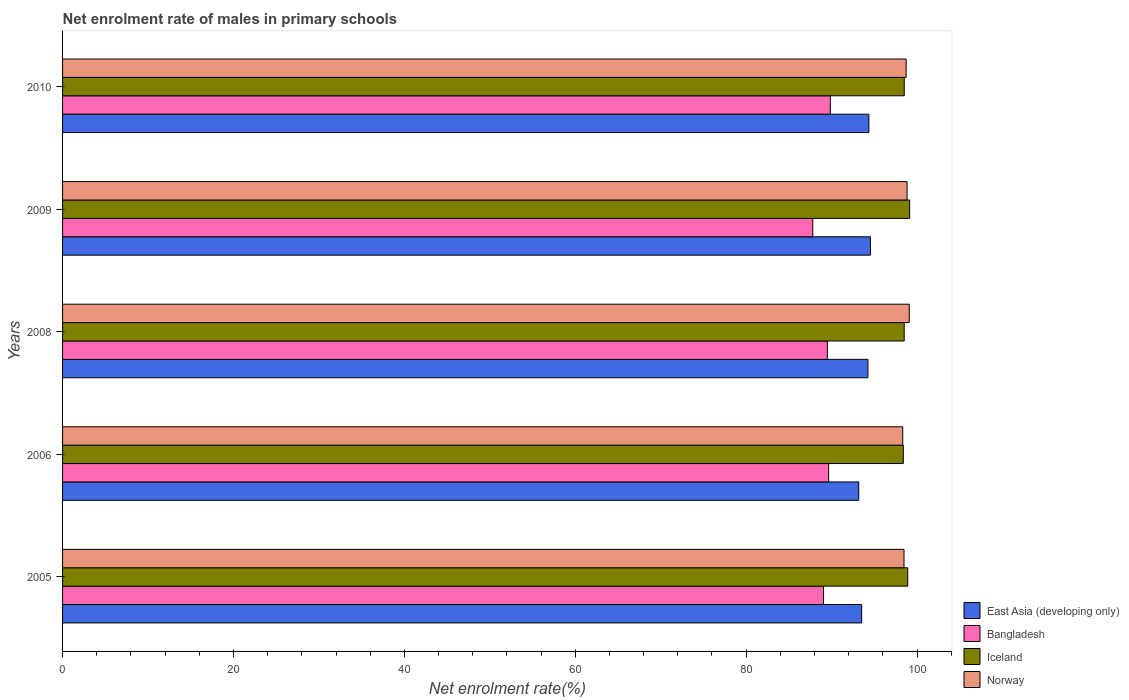How many groups of bars are there?
Ensure brevity in your answer.  5. Are the number of bars per tick equal to the number of legend labels?
Your answer should be very brief. Yes. Are the number of bars on each tick of the Y-axis equal?
Keep it short and to the point. Yes. How many bars are there on the 2nd tick from the top?
Offer a terse response. 4. How many bars are there on the 3rd tick from the bottom?
Provide a short and direct response. 4. What is the label of the 1st group of bars from the top?
Your answer should be compact. 2010. In how many cases, is the number of bars for a given year not equal to the number of legend labels?
Make the answer very short. 0. What is the net enrolment rate of males in primary schools in Norway in 2010?
Offer a very short reply. 98.72. Across all years, what is the maximum net enrolment rate of males in primary schools in Bangladesh?
Ensure brevity in your answer.  89.85. Across all years, what is the minimum net enrolment rate of males in primary schools in Iceland?
Offer a very short reply. 98.39. In which year was the net enrolment rate of males in primary schools in East Asia (developing only) maximum?
Give a very brief answer. 2009. In which year was the net enrolment rate of males in primary schools in Iceland minimum?
Your answer should be compact. 2006. What is the total net enrolment rate of males in primary schools in Iceland in the graph?
Provide a succinct answer. 493.43. What is the difference between the net enrolment rate of males in primary schools in East Asia (developing only) in 2005 and that in 2006?
Make the answer very short. 0.34. What is the difference between the net enrolment rate of males in primary schools in Norway in 2010 and the net enrolment rate of males in primary schools in East Asia (developing only) in 2008?
Offer a very short reply. 4.47. What is the average net enrolment rate of males in primary schools in Iceland per year?
Your answer should be compact. 98.69. In the year 2010, what is the difference between the net enrolment rate of males in primary schools in Iceland and net enrolment rate of males in primary schools in Bangladesh?
Your answer should be compact. 8.66. In how many years, is the net enrolment rate of males in primary schools in Bangladesh greater than 24 %?
Your answer should be very brief. 5. What is the ratio of the net enrolment rate of males in primary schools in Iceland in 2006 to that in 2009?
Keep it short and to the point. 0.99. Is the net enrolment rate of males in primary schools in Bangladesh in 2005 less than that in 2010?
Give a very brief answer. Yes. What is the difference between the highest and the second highest net enrolment rate of males in primary schools in Iceland?
Ensure brevity in your answer.  0.22. What is the difference between the highest and the lowest net enrolment rate of males in primary schools in Iceland?
Keep it short and to the point. 0.74. Is it the case that in every year, the sum of the net enrolment rate of males in primary schools in East Asia (developing only) and net enrolment rate of males in primary schools in Bangladesh is greater than the sum of net enrolment rate of males in primary schools in Iceland and net enrolment rate of males in primary schools in Norway?
Provide a short and direct response. Yes. What does the 4th bar from the top in 2010 represents?
Make the answer very short. East Asia (developing only). Are all the bars in the graph horizontal?
Give a very brief answer. Yes. How many years are there in the graph?
Offer a very short reply. 5. What is the difference between two consecutive major ticks on the X-axis?
Ensure brevity in your answer.  20. Does the graph contain grids?
Give a very brief answer. No. What is the title of the graph?
Ensure brevity in your answer.  Net enrolment rate of males in primary schools. Does "Nigeria" appear as one of the legend labels in the graph?
Your answer should be very brief. No. What is the label or title of the X-axis?
Ensure brevity in your answer.  Net enrolment rate(%). What is the label or title of the Y-axis?
Make the answer very short. Years. What is the Net enrolment rate(%) of East Asia (developing only) in 2005?
Your answer should be compact. 93.52. What is the Net enrolment rate(%) in Bangladesh in 2005?
Provide a short and direct response. 89.05. What is the Net enrolment rate(%) of Iceland in 2005?
Provide a short and direct response. 98.91. What is the Net enrolment rate(%) of Norway in 2005?
Make the answer very short. 98.47. What is the Net enrolment rate(%) in East Asia (developing only) in 2006?
Offer a terse response. 93.17. What is the Net enrolment rate(%) in Bangladesh in 2006?
Your answer should be very brief. 89.65. What is the Net enrolment rate(%) of Iceland in 2006?
Give a very brief answer. 98.39. What is the Net enrolment rate(%) of Norway in 2006?
Give a very brief answer. 98.32. What is the Net enrolment rate(%) of East Asia (developing only) in 2008?
Provide a succinct answer. 94.25. What is the Net enrolment rate(%) of Bangladesh in 2008?
Provide a short and direct response. 89.5. What is the Net enrolment rate(%) in Iceland in 2008?
Provide a short and direct response. 98.49. What is the Net enrolment rate(%) of Norway in 2008?
Make the answer very short. 99.09. What is the Net enrolment rate(%) in East Asia (developing only) in 2009?
Your answer should be very brief. 94.54. What is the Net enrolment rate(%) of Bangladesh in 2009?
Keep it short and to the point. 87.79. What is the Net enrolment rate(%) in Iceland in 2009?
Your answer should be very brief. 99.13. What is the Net enrolment rate(%) of Norway in 2009?
Offer a terse response. 98.83. What is the Net enrolment rate(%) of East Asia (developing only) in 2010?
Give a very brief answer. 94.37. What is the Net enrolment rate(%) in Bangladesh in 2010?
Your answer should be compact. 89.85. What is the Net enrolment rate(%) of Iceland in 2010?
Give a very brief answer. 98.5. What is the Net enrolment rate(%) of Norway in 2010?
Your answer should be compact. 98.72. Across all years, what is the maximum Net enrolment rate(%) of East Asia (developing only)?
Offer a terse response. 94.54. Across all years, what is the maximum Net enrolment rate(%) of Bangladesh?
Ensure brevity in your answer.  89.85. Across all years, what is the maximum Net enrolment rate(%) in Iceland?
Offer a terse response. 99.13. Across all years, what is the maximum Net enrolment rate(%) of Norway?
Make the answer very short. 99.09. Across all years, what is the minimum Net enrolment rate(%) in East Asia (developing only)?
Offer a terse response. 93.17. Across all years, what is the minimum Net enrolment rate(%) of Bangladesh?
Keep it short and to the point. 87.79. Across all years, what is the minimum Net enrolment rate(%) of Iceland?
Offer a very short reply. 98.39. Across all years, what is the minimum Net enrolment rate(%) of Norway?
Your answer should be compact. 98.32. What is the total Net enrolment rate(%) in East Asia (developing only) in the graph?
Your answer should be very brief. 469.85. What is the total Net enrolment rate(%) of Bangladesh in the graph?
Give a very brief answer. 445.85. What is the total Net enrolment rate(%) in Iceland in the graph?
Your answer should be compact. 493.43. What is the total Net enrolment rate(%) of Norway in the graph?
Offer a terse response. 493.43. What is the difference between the Net enrolment rate(%) in East Asia (developing only) in 2005 and that in 2006?
Ensure brevity in your answer.  0.34. What is the difference between the Net enrolment rate(%) of Bangladesh in 2005 and that in 2006?
Offer a very short reply. -0.6. What is the difference between the Net enrolment rate(%) of Iceland in 2005 and that in 2006?
Your answer should be compact. 0.52. What is the difference between the Net enrolment rate(%) in Norway in 2005 and that in 2006?
Your answer should be compact. 0.15. What is the difference between the Net enrolment rate(%) of East Asia (developing only) in 2005 and that in 2008?
Provide a short and direct response. -0.73. What is the difference between the Net enrolment rate(%) in Bangladesh in 2005 and that in 2008?
Keep it short and to the point. -0.45. What is the difference between the Net enrolment rate(%) of Iceland in 2005 and that in 2008?
Offer a terse response. 0.42. What is the difference between the Net enrolment rate(%) in Norway in 2005 and that in 2008?
Make the answer very short. -0.61. What is the difference between the Net enrolment rate(%) in East Asia (developing only) in 2005 and that in 2009?
Give a very brief answer. -1.02. What is the difference between the Net enrolment rate(%) in Bangladesh in 2005 and that in 2009?
Give a very brief answer. 1.26. What is the difference between the Net enrolment rate(%) of Iceland in 2005 and that in 2009?
Give a very brief answer. -0.22. What is the difference between the Net enrolment rate(%) of Norway in 2005 and that in 2009?
Make the answer very short. -0.36. What is the difference between the Net enrolment rate(%) in East Asia (developing only) in 2005 and that in 2010?
Make the answer very short. -0.85. What is the difference between the Net enrolment rate(%) in Bangladesh in 2005 and that in 2010?
Keep it short and to the point. -0.79. What is the difference between the Net enrolment rate(%) of Iceland in 2005 and that in 2010?
Your answer should be very brief. 0.41. What is the difference between the Net enrolment rate(%) in Norway in 2005 and that in 2010?
Provide a succinct answer. -0.25. What is the difference between the Net enrolment rate(%) in East Asia (developing only) in 2006 and that in 2008?
Offer a terse response. -1.08. What is the difference between the Net enrolment rate(%) in Bangladesh in 2006 and that in 2008?
Give a very brief answer. 0.15. What is the difference between the Net enrolment rate(%) of Iceland in 2006 and that in 2008?
Offer a very short reply. -0.1. What is the difference between the Net enrolment rate(%) in Norway in 2006 and that in 2008?
Offer a terse response. -0.76. What is the difference between the Net enrolment rate(%) in East Asia (developing only) in 2006 and that in 2009?
Make the answer very short. -1.37. What is the difference between the Net enrolment rate(%) of Bangladesh in 2006 and that in 2009?
Make the answer very short. 1.86. What is the difference between the Net enrolment rate(%) of Iceland in 2006 and that in 2009?
Provide a succinct answer. -0.74. What is the difference between the Net enrolment rate(%) of Norway in 2006 and that in 2009?
Your answer should be very brief. -0.51. What is the difference between the Net enrolment rate(%) in East Asia (developing only) in 2006 and that in 2010?
Provide a succinct answer. -1.19. What is the difference between the Net enrolment rate(%) of Bangladesh in 2006 and that in 2010?
Make the answer very short. -0.19. What is the difference between the Net enrolment rate(%) of Iceland in 2006 and that in 2010?
Your answer should be compact. -0.11. What is the difference between the Net enrolment rate(%) in Norway in 2006 and that in 2010?
Make the answer very short. -0.4. What is the difference between the Net enrolment rate(%) of East Asia (developing only) in 2008 and that in 2009?
Provide a short and direct response. -0.29. What is the difference between the Net enrolment rate(%) in Bangladesh in 2008 and that in 2009?
Your answer should be compact. 1.71. What is the difference between the Net enrolment rate(%) in Iceland in 2008 and that in 2009?
Offer a very short reply. -0.64. What is the difference between the Net enrolment rate(%) of Norway in 2008 and that in 2009?
Provide a short and direct response. 0.26. What is the difference between the Net enrolment rate(%) of East Asia (developing only) in 2008 and that in 2010?
Make the answer very short. -0.11. What is the difference between the Net enrolment rate(%) of Bangladesh in 2008 and that in 2010?
Your answer should be very brief. -0.34. What is the difference between the Net enrolment rate(%) of Iceland in 2008 and that in 2010?
Offer a terse response. -0.01. What is the difference between the Net enrolment rate(%) in Norway in 2008 and that in 2010?
Your answer should be very brief. 0.36. What is the difference between the Net enrolment rate(%) in East Asia (developing only) in 2009 and that in 2010?
Give a very brief answer. 0.17. What is the difference between the Net enrolment rate(%) in Bangladesh in 2009 and that in 2010?
Keep it short and to the point. -2.05. What is the difference between the Net enrolment rate(%) in Iceland in 2009 and that in 2010?
Offer a very short reply. 0.63. What is the difference between the Net enrolment rate(%) in Norway in 2009 and that in 2010?
Give a very brief answer. 0.11. What is the difference between the Net enrolment rate(%) of East Asia (developing only) in 2005 and the Net enrolment rate(%) of Bangladesh in 2006?
Your answer should be compact. 3.86. What is the difference between the Net enrolment rate(%) in East Asia (developing only) in 2005 and the Net enrolment rate(%) in Iceland in 2006?
Offer a very short reply. -4.88. What is the difference between the Net enrolment rate(%) of East Asia (developing only) in 2005 and the Net enrolment rate(%) of Norway in 2006?
Your answer should be compact. -4.81. What is the difference between the Net enrolment rate(%) of Bangladesh in 2005 and the Net enrolment rate(%) of Iceland in 2006?
Offer a terse response. -9.34. What is the difference between the Net enrolment rate(%) in Bangladesh in 2005 and the Net enrolment rate(%) in Norway in 2006?
Provide a short and direct response. -9.27. What is the difference between the Net enrolment rate(%) in Iceland in 2005 and the Net enrolment rate(%) in Norway in 2006?
Ensure brevity in your answer.  0.59. What is the difference between the Net enrolment rate(%) in East Asia (developing only) in 2005 and the Net enrolment rate(%) in Bangladesh in 2008?
Provide a short and direct response. 4.01. What is the difference between the Net enrolment rate(%) in East Asia (developing only) in 2005 and the Net enrolment rate(%) in Iceland in 2008?
Provide a short and direct response. -4.98. What is the difference between the Net enrolment rate(%) of East Asia (developing only) in 2005 and the Net enrolment rate(%) of Norway in 2008?
Your response must be concise. -5.57. What is the difference between the Net enrolment rate(%) in Bangladesh in 2005 and the Net enrolment rate(%) in Iceland in 2008?
Ensure brevity in your answer.  -9.44. What is the difference between the Net enrolment rate(%) in Bangladesh in 2005 and the Net enrolment rate(%) in Norway in 2008?
Your answer should be compact. -10.03. What is the difference between the Net enrolment rate(%) in Iceland in 2005 and the Net enrolment rate(%) in Norway in 2008?
Give a very brief answer. -0.17. What is the difference between the Net enrolment rate(%) of East Asia (developing only) in 2005 and the Net enrolment rate(%) of Bangladesh in 2009?
Give a very brief answer. 5.72. What is the difference between the Net enrolment rate(%) of East Asia (developing only) in 2005 and the Net enrolment rate(%) of Iceland in 2009?
Ensure brevity in your answer.  -5.61. What is the difference between the Net enrolment rate(%) in East Asia (developing only) in 2005 and the Net enrolment rate(%) in Norway in 2009?
Provide a short and direct response. -5.31. What is the difference between the Net enrolment rate(%) of Bangladesh in 2005 and the Net enrolment rate(%) of Iceland in 2009?
Offer a very short reply. -10.08. What is the difference between the Net enrolment rate(%) in Bangladesh in 2005 and the Net enrolment rate(%) in Norway in 2009?
Your response must be concise. -9.78. What is the difference between the Net enrolment rate(%) in Iceland in 2005 and the Net enrolment rate(%) in Norway in 2009?
Offer a terse response. 0.08. What is the difference between the Net enrolment rate(%) in East Asia (developing only) in 2005 and the Net enrolment rate(%) in Bangladesh in 2010?
Ensure brevity in your answer.  3.67. What is the difference between the Net enrolment rate(%) of East Asia (developing only) in 2005 and the Net enrolment rate(%) of Iceland in 2010?
Ensure brevity in your answer.  -4.98. What is the difference between the Net enrolment rate(%) in East Asia (developing only) in 2005 and the Net enrolment rate(%) in Norway in 2010?
Provide a short and direct response. -5.21. What is the difference between the Net enrolment rate(%) in Bangladesh in 2005 and the Net enrolment rate(%) in Iceland in 2010?
Provide a short and direct response. -9.45. What is the difference between the Net enrolment rate(%) of Bangladesh in 2005 and the Net enrolment rate(%) of Norway in 2010?
Make the answer very short. -9.67. What is the difference between the Net enrolment rate(%) of Iceland in 2005 and the Net enrolment rate(%) of Norway in 2010?
Your answer should be very brief. 0.19. What is the difference between the Net enrolment rate(%) in East Asia (developing only) in 2006 and the Net enrolment rate(%) in Bangladesh in 2008?
Provide a short and direct response. 3.67. What is the difference between the Net enrolment rate(%) of East Asia (developing only) in 2006 and the Net enrolment rate(%) of Iceland in 2008?
Give a very brief answer. -5.32. What is the difference between the Net enrolment rate(%) in East Asia (developing only) in 2006 and the Net enrolment rate(%) in Norway in 2008?
Provide a succinct answer. -5.91. What is the difference between the Net enrolment rate(%) in Bangladesh in 2006 and the Net enrolment rate(%) in Iceland in 2008?
Offer a very short reply. -8.84. What is the difference between the Net enrolment rate(%) of Bangladesh in 2006 and the Net enrolment rate(%) of Norway in 2008?
Provide a succinct answer. -9.43. What is the difference between the Net enrolment rate(%) of Iceland in 2006 and the Net enrolment rate(%) of Norway in 2008?
Offer a very short reply. -0.69. What is the difference between the Net enrolment rate(%) of East Asia (developing only) in 2006 and the Net enrolment rate(%) of Bangladesh in 2009?
Your answer should be very brief. 5.38. What is the difference between the Net enrolment rate(%) in East Asia (developing only) in 2006 and the Net enrolment rate(%) in Iceland in 2009?
Keep it short and to the point. -5.96. What is the difference between the Net enrolment rate(%) in East Asia (developing only) in 2006 and the Net enrolment rate(%) in Norway in 2009?
Your answer should be very brief. -5.66. What is the difference between the Net enrolment rate(%) in Bangladesh in 2006 and the Net enrolment rate(%) in Iceland in 2009?
Ensure brevity in your answer.  -9.48. What is the difference between the Net enrolment rate(%) in Bangladesh in 2006 and the Net enrolment rate(%) in Norway in 2009?
Offer a terse response. -9.18. What is the difference between the Net enrolment rate(%) in Iceland in 2006 and the Net enrolment rate(%) in Norway in 2009?
Your response must be concise. -0.44. What is the difference between the Net enrolment rate(%) of East Asia (developing only) in 2006 and the Net enrolment rate(%) of Bangladesh in 2010?
Your answer should be compact. 3.33. What is the difference between the Net enrolment rate(%) in East Asia (developing only) in 2006 and the Net enrolment rate(%) in Iceland in 2010?
Provide a succinct answer. -5.33. What is the difference between the Net enrolment rate(%) of East Asia (developing only) in 2006 and the Net enrolment rate(%) of Norway in 2010?
Offer a terse response. -5.55. What is the difference between the Net enrolment rate(%) in Bangladesh in 2006 and the Net enrolment rate(%) in Iceland in 2010?
Your answer should be compact. -8.85. What is the difference between the Net enrolment rate(%) in Bangladesh in 2006 and the Net enrolment rate(%) in Norway in 2010?
Make the answer very short. -9.07. What is the difference between the Net enrolment rate(%) of Iceland in 2006 and the Net enrolment rate(%) of Norway in 2010?
Your answer should be compact. -0.33. What is the difference between the Net enrolment rate(%) in East Asia (developing only) in 2008 and the Net enrolment rate(%) in Bangladesh in 2009?
Provide a succinct answer. 6.46. What is the difference between the Net enrolment rate(%) of East Asia (developing only) in 2008 and the Net enrolment rate(%) of Iceland in 2009?
Your answer should be compact. -4.88. What is the difference between the Net enrolment rate(%) of East Asia (developing only) in 2008 and the Net enrolment rate(%) of Norway in 2009?
Give a very brief answer. -4.58. What is the difference between the Net enrolment rate(%) in Bangladesh in 2008 and the Net enrolment rate(%) in Iceland in 2009?
Your answer should be compact. -9.63. What is the difference between the Net enrolment rate(%) of Bangladesh in 2008 and the Net enrolment rate(%) of Norway in 2009?
Keep it short and to the point. -9.33. What is the difference between the Net enrolment rate(%) of Iceland in 2008 and the Net enrolment rate(%) of Norway in 2009?
Offer a very short reply. -0.34. What is the difference between the Net enrolment rate(%) in East Asia (developing only) in 2008 and the Net enrolment rate(%) in Bangladesh in 2010?
Your answer should be very brief. 4.41. What is the difference between the Net enrolment rate(%) of East Asia (developing only) in 2008 and the Net enrolment rate(%) of Iceland in 2010?
Provide a short and direct response. -4.25. What is the difference between the Net enrolment rate(%) in East Asia (developing only) in 2008 and the Net enrolment rate(%) in Norway in 2010?
Keep it short and to the point. -4.47. What is the difference between the Net enrolment rate(%) of Bangladesh in 2008 and the Net enrolment rate(%) of Iceland in 2010?
Offer a terse response. -9. What is the difference between the Net enrolment rate(%) in Bangladesh in 2008 and the Net enrolment rate(%) in Norway in 2010?
Your answer should be compact. -9.22. What is the difference between the Net enrolment rate(%) in Iceland in 2008 and the Net enrolment rate(%) in Norway in 2010?
Make the answer very short. -0.23. What is the difference between the Net enrolment rate(%) of East Asia (developing only) in 2009 and the Net enrolment rate(%) of Bangladesh in 2010?
Offer a terse response. 4.69. What is the difference between the Net enrolment rate(%) in East Asia (developing only) in 2009 and the Net enrolment rate(%) in Iceland in 2010?
Ensure brevity in your answer.  -3.96. What is the difference between the Net enrolment rate(%) in East Asia (developing only) in 2009 and the Net enrolment rate(%) in Norway in 2010?
Make the answer very short. -4.18. What is the difference between the Net enrolment rate(%) in Bangladesh in 2009 and the Net enrolment rate(%) in Iceland in 2010?
Your answer should be very brief. -10.71. What is the difference between the Net enrolment rate(%) of Bangladesh in 2009 and the Net enrolment rate(%) of Norway in 2010?
Provide a short and direct response. -10.93. What is the difference between the Net enrolment rate(%) of Iceland in 2009 and the Net enrolment rate(%) of Norway in 2010?
Your answer should be very brief. 0.41. What is the average Net enrolment rate(%) of East Asia (developing only) per year?
Your answer should be very brief. 93.97. What is the average Net enrolment rate(%) in Bangladesh per year?
Ensure brevity in your answer.  89.17. What is the average Net enrolment rate(%) in Iceland per year?
Your answer should be compact. 98.69. What is the average Net enrolment rate(%) in Norway per year?
Provide a succinct answer. 98.69. In the year 2005, what is the difference between the Net enrolment rate(%) in East Asia (developing only) and Net enrolment rate(%) in Bangladesh?
Offer a terse response. 4.46. In the year 2005, what is the difference between the Net enrolment rate(%) of East Asia (developing only) and Net enrolment rate(%) of Iceland?
Make the answer very short. -5.39. In the year 2005, what is the difference between the Net enrolment rate(%) of East Asia (developing only) and Net enrolment rate(%) of Norway?
Provide a succinct answer. -4.95. In the year 2005, what is the difference between the Net enrolment rate(%) of Bangladesh and Net enrolment rate(%) of Iceland?
Make the answer very short. -9.86. In the year 2005, what is the difference between the Net enrolment rate(%) in Bangladesh and Net enrolment rate(%) in Norway?
Provide a short and direct response. -9.42. In the year 2005, what is the difference between the Net enrolment rate(%) of Iceland and Net enrolment rate(%) of Norway?
Make the answer very short. 0.44. In the year 2006, what is the difference between the Net enrolment rate(%) of East Asia (developing only) and Net enrolment rate(%) of Bangladesh?
Make the answer very short. 3.52. In the year 2006, what is the difference between the Net enrolment rate(%) of East Asia (developing only) and Net enrolment rate(%) of Iceland?
Your answer should be very brief. -5.22. In the year 2006, what is the difference between the Net enrolment rate(%) of East Asia (developing only) and Net enrolment rate(%) of Norway?
Give a very brief answer. -5.15. In the year 2006, what is the difference between the Net enrolment rate(%) in Bangladesh and Net enrolment rate(%) in Iceland?
Provide a short and direct response. -8.74. In the year 2006, what is the difference between the Net enrolment rate(%) in Bangladesh and Net enrolment rate(%) in Norway?
Your answer should be compact. -8.67. In the year 2006, what is the difference between the Net enrolment rate(%) of Iceland and Net enrolment rate(%) of Norway?
Your answer should be compact. 0.07. In the year 2008, what is the difference between the Net enrolment rate(%) of East Asia (developing only) and Net enrolment rate(%) of Bangladesh?
Your answer should be compact. 4.75. In the year 2008, what is the difference between the Net enrolment rate(%) in East Asia (developing only) and Net enrolment rate(%) in Iceland?
Provide a short and direct response. -4.24. In the year 2008, what is the difference between the Net enrolment rate(%) in East Asia (developing only) and Net enrolment rate(%) in Norway?
Ensure brevity in your answer.  -4.83. In the year 2008, what is the difference between the Net enrolment rate(%) in Bangladesh and Net enrolment rate(%) in Iceland?
Make the answer very short. -8.99. In the year 2008, what is the difference between the Net enrolment rate(%) of Bangladesh and Net enrolment rate(%) of Norway?
Your answer should be very brief. -9.58. In the year 2008, what is the difference between the Net enrolment rate(%) of Iceland and Net enrolment rate(%) of Norway?
Give a very brief answer. -0.59. In the year 2009, what is the difference between the Net enrolment rate(%) in East Asia (developing only) and Net enrolment rate(%) in Bangladesh?
Give a very brief answer. 6.75. In the year 2009, what is the difference between the Net enrolment rate(%) of East Asia (developing only) and Net enrolment rate(%) of Iceland?
Keep it short and to the point. -4.59. In the year 2009, what is the difference between the Net enrolment rate(%) in East Asia (developing only) and Net enrolment rate(%) in Norway?
Ensure brevity in your answer.  -4.29. In the year 2009, what is the difference between the Net enrolment rate(%) in Bangladesh and Net enrolment rate(%) in Iceland?
Provide a succinct answer. -11.34. In the year 2009, what is the difference between the Net enrolment rate(%) in Bangladesh and Net enrolment rate(%) in Norway?
Offer a terse response. -11.04. In the year 2009, what is the difference between the Net enrolment rate(%) in Iceland and Net enrolment rate(%) in Norway?
Offer a terse response. 0.3. In the year 2010, what is the difference between the Net enrolment rate(%) in East Asia (developing only) and Net enrolment rate(%) in Bangladesh?
Your answer should be compact. 4.52. In the year 2010, what is the difference between the Net enrolment rate(%) of East Asia (developing only) and Net enrolment rate(%) of Iceland?
Ensure brevity in your answer.  -4.14. In the year 2010, what is the difference between the Net enrolment rate(%) of East Asia (developing only) and Net enrolment rate(%) of Norway?
Your response must be concise. -4.36. In the year 2010, what is the difference between the Net enrolment rate(%) of Bangladesh and Net enrolment rate(%) of Iceland?
Offer a terse response. -8.66. In the year 2010, what is the difference between the Net enrolment rate(%) in Bangladesh and Net enrolment rate(%) in Norway?
Offer a terse response. -8.88. In the year 2010, what is the difference between the Net enrolment rate(%) in Iceland and Net enrolment rate(%) in Norway?
Provide a short and direct response. -0.22. What is the ratio of the Net enrolment rate(%) of East Asia (developing only) in 2005 to that in 2006?
Give a very brief answer. 1. What is the ratio of the Net enrolment rate(%) in Bangladesh in 2005 to that in 2006?
Offer a terse response. 0.99. What is the ratio of the Net enrolment rate(%) in Iceland in 2005 to that in 2006?
Offer a terse response. 1.01. What is the ratio of the Net enrolment rate(%) in Norway in 2005 to that in 2006?
Your answer should be compact. 1. What is the ratio of the Net enrolment rate(%) of East Asia (developing only) in 2005 to that in 2008?
Your response must be concise. 0.99. What is the ratio of the Net enrolment rate(%) of Iceland in 2005 to that in 2008?
Your answer should be compact. 1. What is the ratio of the Net enrolment rate(%) in East Asia (developing only) in 2005 to that in 2009?
Give a very brief answer. 0.99. What is the ratio of the Net enrolment rate(%) in Bangladesh in 2005 to that in 2009?
Your answer should be very brief. 1.01. What is the ratio of the Net enrolment rate(%) in Iceland in 2005 to that in 2009?
Keep it short and to the point. 1. What is the ratio of the Net enrolment rate(%) in Norway in 2005 to that in 2009?
Provide a short and direct response. 1. What is the ratio of the Net enrolment rate(%) of Iceland in 2005 to that in 2010?
Your response must be concise. 1. What is the ratio of the Net enrolment rate(%) of East Asia (developing only) in 2006 to that in 2008?
Provide a succinct answer. 0.99. What is the ratio of the Net enrolment rate(%) of Bangladesh in 2006 to that in 2008?
Offer a very short reply. 1. What is the ratio of the Net enrolment rate(%) in Iceland in 2006 to that in 2008?
Provide a succinct answer. 1. What is the ratio of the Net enrolment rate(%) of East Asia (developing only) in 2006 to that in 2009?
Give a very brief answer. 0.99. What is the ratio of the Net enrolment rate(%) in Bangladesh in 2006 to that in 2009?
Provide a short and direct response. 1.02. What is the ratio of the Net enrolment rate(%) of Iceland in 2006 to that in 2009?
Keep it short and to the point. 0.99. What is the ratio of the Net enrolment rate(%) of Norway in 2006 to that in 2009?
Keep it short and to the point. 0.99. What is the ratio of the Net enrolment rate(%) in East Asia (developing only) in 2006 to that in 2010?
Offer a very short reply. 0.99. What is the ratio of the Net enrolment rate(%) in Bangladesh in 2006 to that in 2010?
Keep it short and to the point. 1. What is the ratio of the Net enrolment rate(%) of East Asia (developing only) in 2008 to that in 2009?
Your answer should be compact. 1. What is the ratio of the Net enrolment rate(%) of Bangladesh in 2008 to that in 2009?
Offer a very short reply. 1.02. What is the ratio of the Net enrolment rate(%) of Iceland in 2008 to that in 2010?
Ensure brevity in your answer.  1. What is the ratio of the Net enrolment rate(%) of Bangladesh in 2009 to that in 2010?
Offer a very short reply. 0.98. What is the ratio of the Net enrolment rate(%) of Iceland in 2009 to that in 2010?
Your response must be concise. 1.01. What is the ratio of the Net enrolment rate(%) in Norway in 2009 to that in 2010?
Provide a short and direct response. 1. What is the difference between the highest and the second highest Net enrolment rate(%) in East Asia (developing only)?
Offer a very short reply. 0.17. What is the difference between the highest and the second highest Net enrolment rate(%) of Bangladesh?
Offer a terse response. 0.19. What is the difference between the highest and the second highest Net enrolment rate(%) in Iceland?
Keep it short and to the point. 0.22. What is the difference between the highest and the second highest Net enrolment rate(%) in Norway?
Provide a short and direct response. 0.26. What is the difference between the highest and the lowest Net enrolment rate(%) in East Asia (developing only)?
Provide a short and direct response. 1.37. What is the difference between the highest and the lowest Net enrolment rate(%) of Bangladesh?
Make the answer very short. 2.05. What is the difference between the highest and the lowest Net enrolment rate(%) of Iceland?
Ensure brevity in your answer.  0.74. What is the difference between the highest and the lowest Net enrolment rate(%) of Norway?
Ensure brevity in your answer.  0.76. 